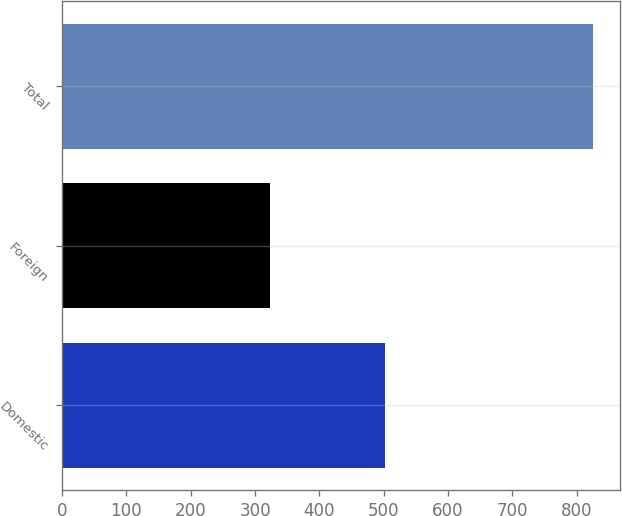Convert chart. <chart><loc_0><loc_0><loc_500><loc_500><bar_chart><fcel>Domestic<fcel>Foreign<fcel>Total<nl><fcel>502.1<fcel>323.5<fcel>825.6<nl></chart> 